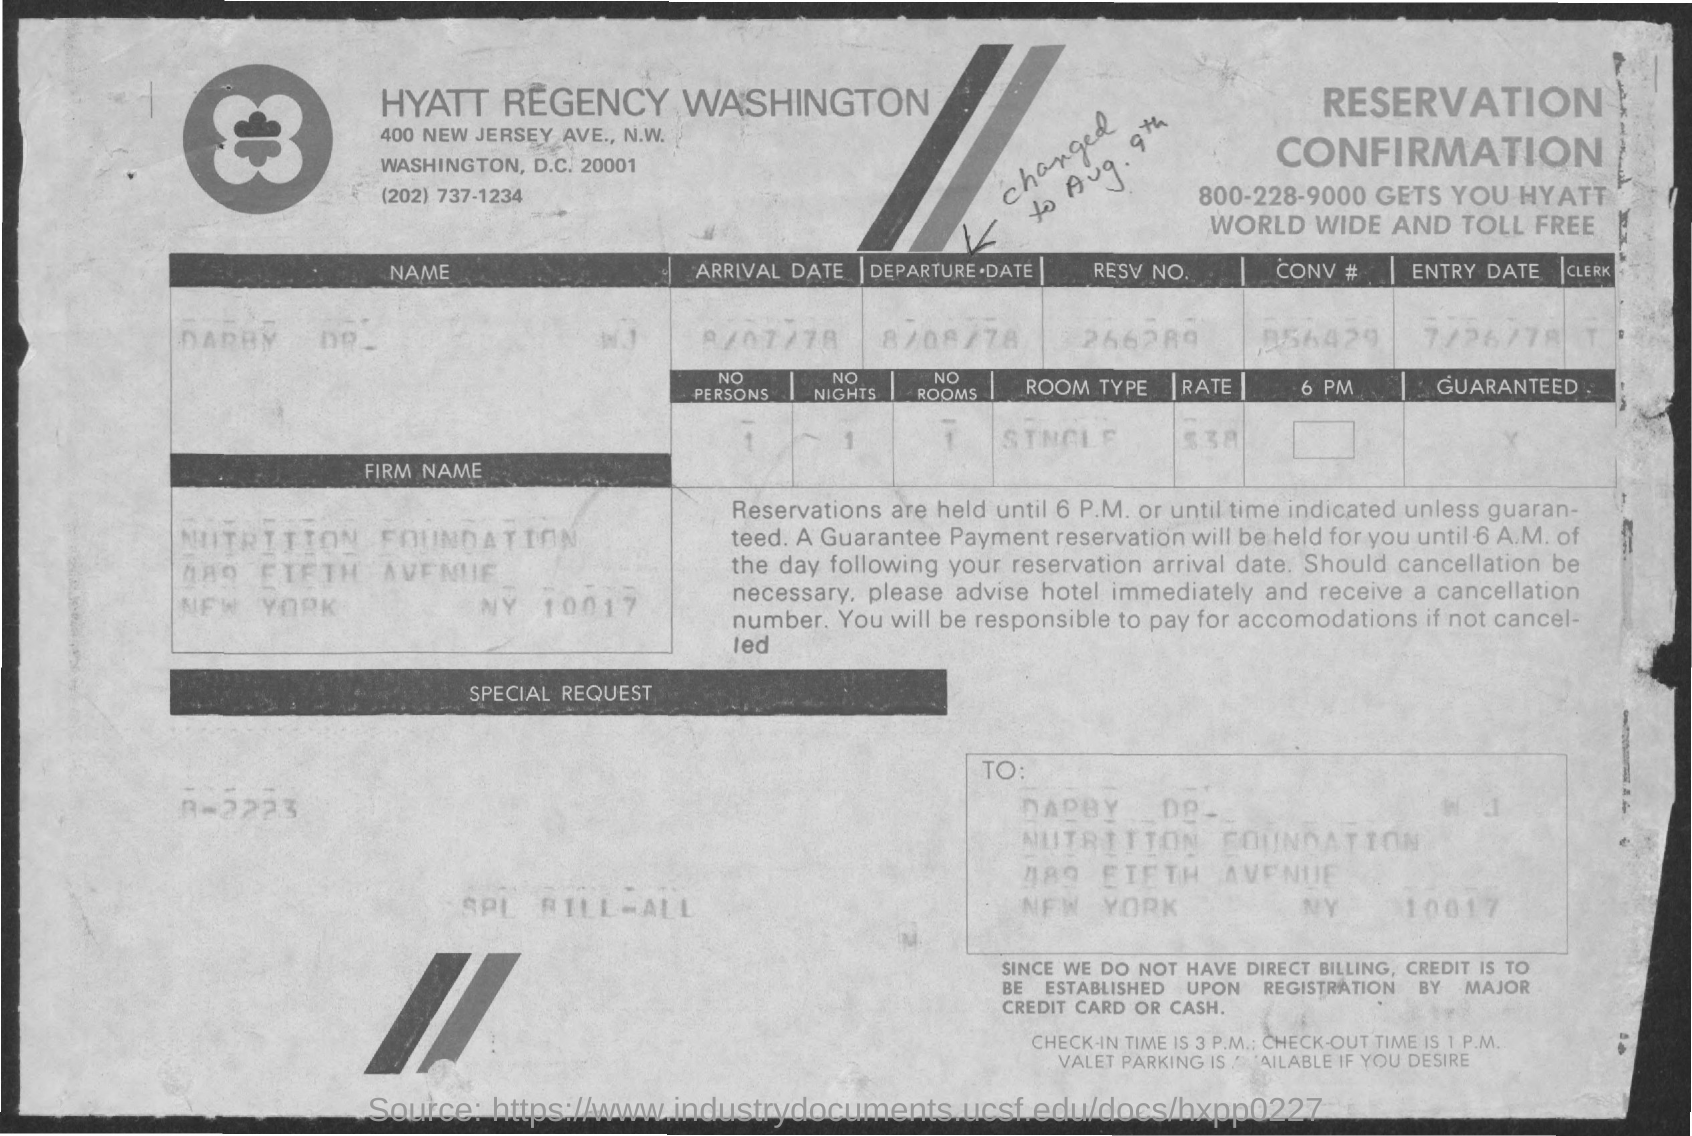what is the entry date mentioned ? The entry date mentioned on the document is the 26th of July, 1978. This date refers to when the hotel reservation was logged or processed in the system. 